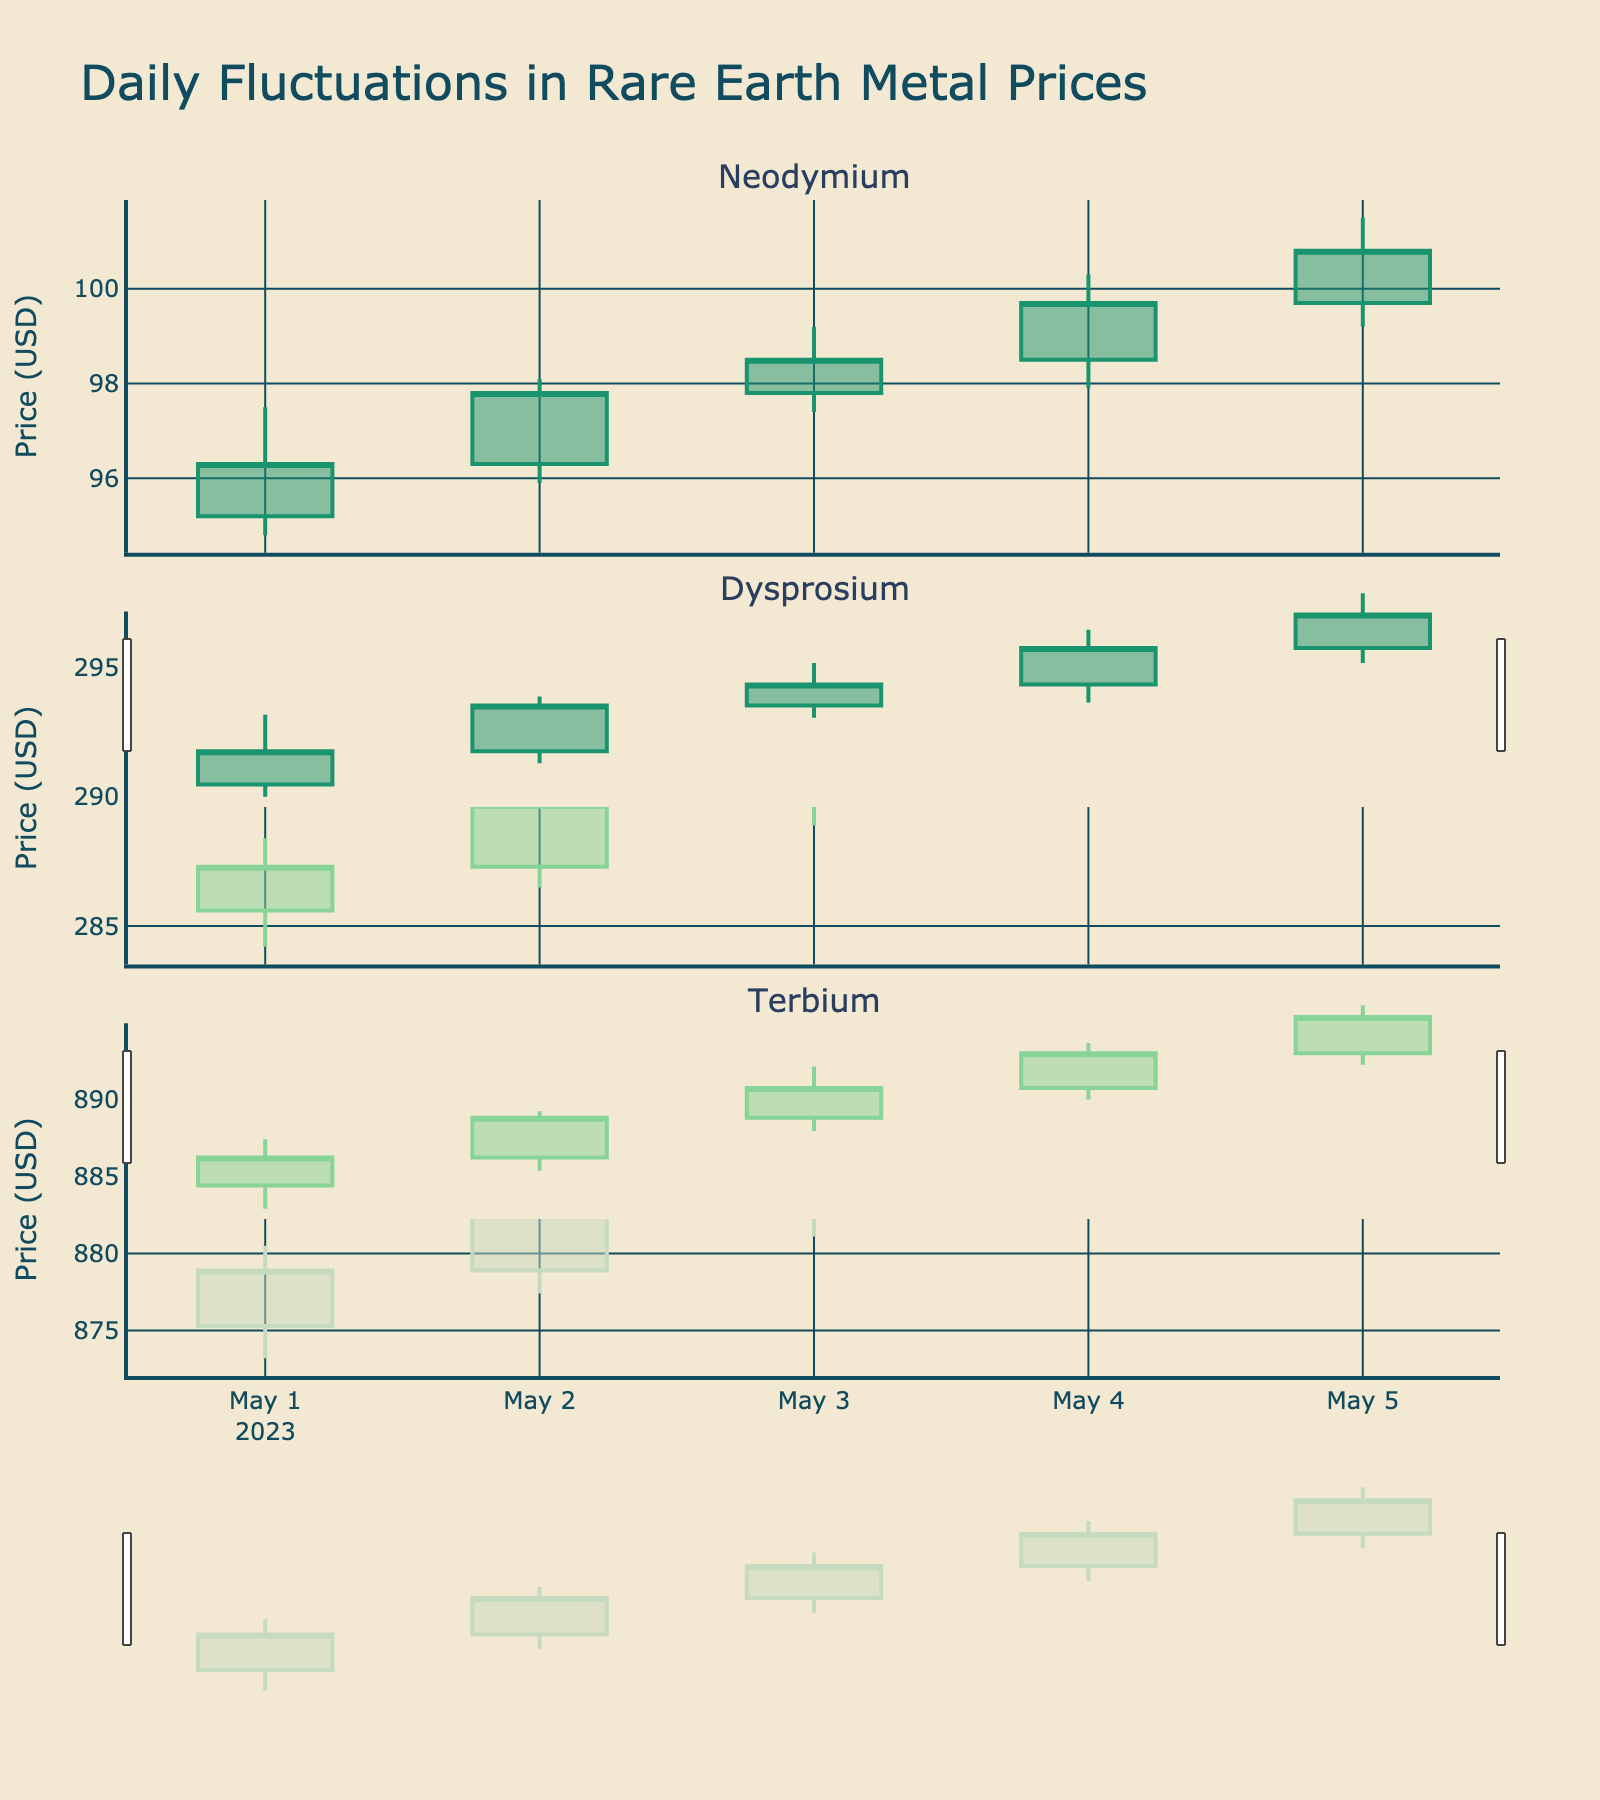What's the overall title of the figure? The title is displayed prominently at the top center of the figure. It reads "Daily Fluctuations in Rare Earth Metal Prices".
Answer: Daily Fluctuations in Rare Earth Metal Prices Which metal showed the highest price on May 5th? To identify the metal with the highest price, compare the "High" prices of Neodymium, Dysprosium, and Terbium on May 5th. The prices are 101.50, 296.50, and 893.80 respectively. Terbium has the highest price.
Answer: Terbium Over the 5-day period, on which day did Dysprosium have the lowest closing price? Reviewing the closing prices of Dysprosium from the data for each day, the values are 287.30, 289.70, 291.50, 293.60, and 295.80. The lowest value is 287.30, which corresponds to May 1st.
Answer: May 1st Which metal had the steepest increase in closing price from May 1st to May 5th? Calculate the difference in closing prices for each metal from May 1st to May 5th. For Neodymium: 100.80 - 96.30 = 4.50. For Dysprosium: 295.80 - 287.30 = 8.50. For Terbium: 892.50 - 878.90 = 13.60. Terbium has the greatest increase.
Answer: Terbium Did any of the metals have a consistent increase in their closing prices over the five days? Which one(s)? Examine the trend of closing prices for each metal day by day. Neodymium: 96.30, 97.80, 98.50, 99.70, 100.80 (consistent increase). Dysprosium: 287.30, 289.70, 291.50, 293.60, 295.80 (consistent increase). Terbium: 878.90, 882.60, 885.80, 889.10, 892.50 (consistent increase). All three metals show a consistent increase.
Answer: Neodymium, Dysprosium, Terbium On which specific day did Terbium experience the highest volatility, and how is this determined? Volatility can be measured by the range (High - Low) for each day. For Terbium, the ranges are 7.30 (May 1), 6.30 (May 2), 6.10 (May 3), 6.10 (May 4), and 6.20 (May 5). The highest range is 7.30 on May 1.
Answer: May 1 How did the price range (difference between High and Low) of Neodymium change over the days? Calculate the price range for Neodymium each day: May 1: 97.50 - 94.80 = 2.70, May 2: 98.10 - 95.90 = 2.20, May 3: 99.20 - 97.40 = 1.80, May 4: 100.30 - 97.90 = 2.40, May 5: 101.50 - 99.20 = 2.30.
Answer: 2.70, 2.20, 1.80, 2.40, 2.30 Which metal showed the least fluctuation in its closing price throughout the period? Calculate the range of closing prices for each metal. Neodymium: 100.80 - 96.30 = 4.50, Dysprosium: 295.80 - 287.30 = 8.50, Terbium: 892.50 - 878.90 = 13.60. Neodymium has the smallest range.
Answer: Neodymium 